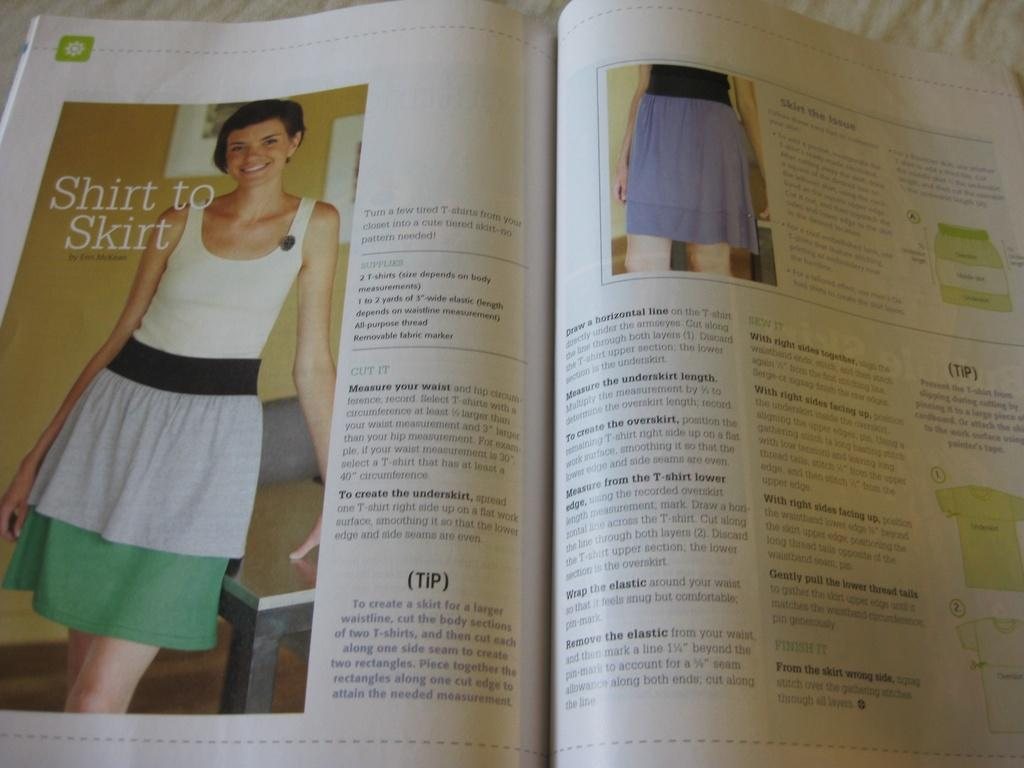<image>
Create a compact narrative representing the image presented. An article describes how to change a shirt into a skirt. 